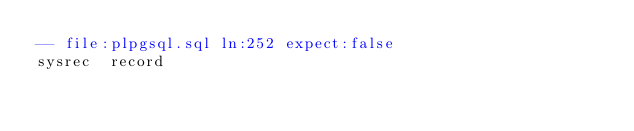Convert code to text. <code><loc_0><loc_0><loc_500><loc_500><_SQL_>-- file:plpgsql.sql ln:252 expect:false
sysrec	record
</code> 